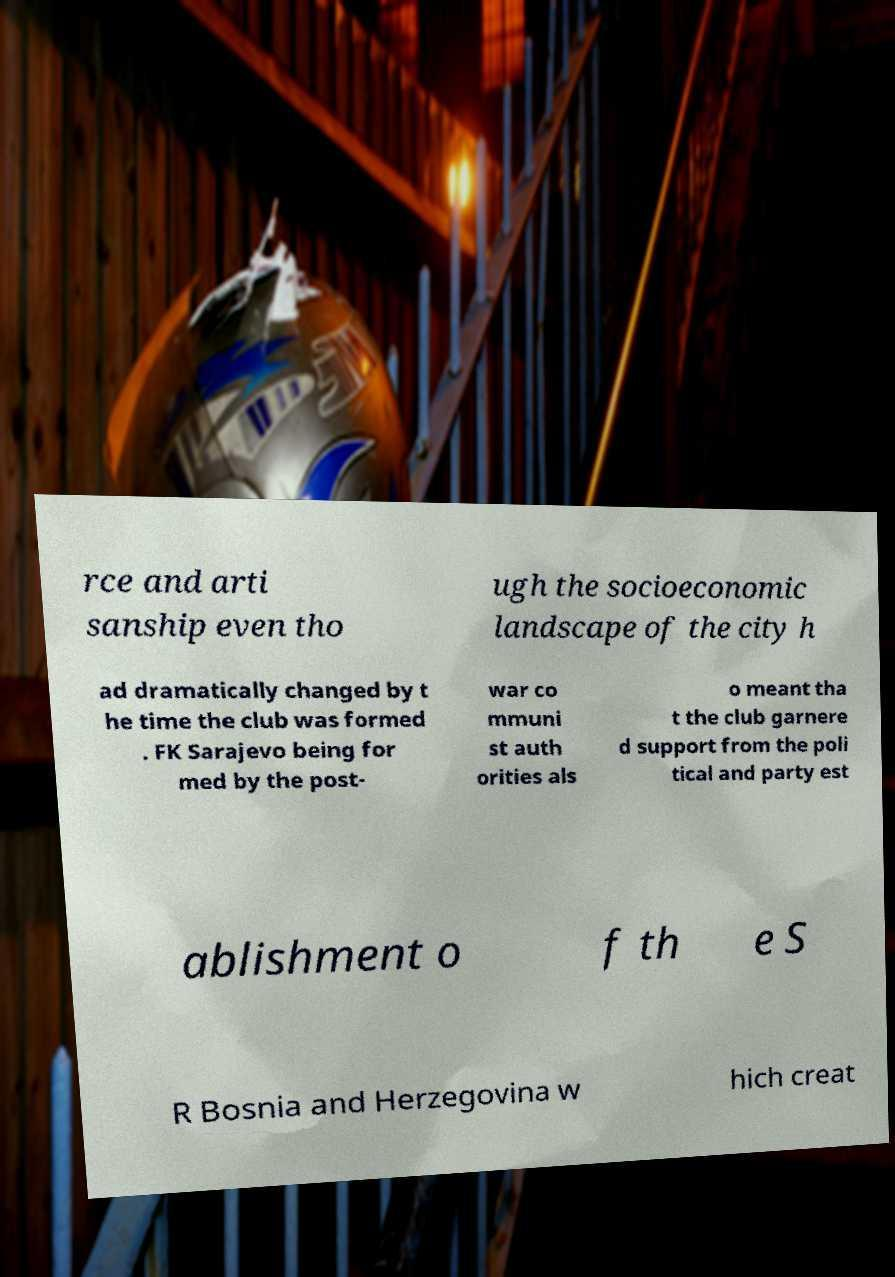For documentation purposes, I need the text within this image transcribed. Could you provide that? rce and arti sanship even tho ugh the socioeconomic landscape of the city h ad dramatically changed by t he time the club was formed . FK Sarajevo being for med by the post- war co mmuni st auth orities als o meant tha t the club garnere d support from the poli tical and party est ablishment o f th e S R Bosnia and Herzegovina w hich creat 